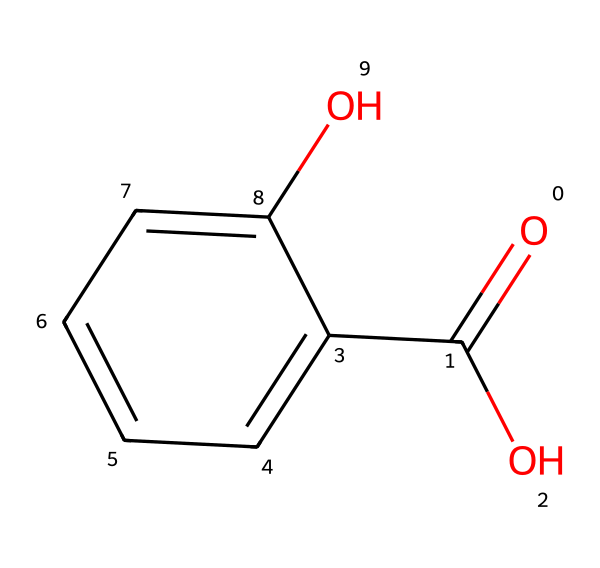What is the molecular formula of salicylic acid? To deduce the molecular formula, count the number of each type of atom in the SMILES representation: there are 7 carbons (C), 6 hydrogens (H), and 3 oxygens (O), which gives the formula C7H6O3.
Answer: C7H6O3 How many hydroxyl groups are present in salicylic acid? In the chemical structure, look for the -OH functional groups. There is one hydroxyl group attached directly to the benzene ring and another as part of the carboxylic acid, totaling two.
Answer: 2 What type of functional groups are present in salicylic acid? Identify the functional groups in the structure: the presence of both -OH (hydroxyl) and -COOH (carboxylic acid) groups determines the classification.
Answer: hydroxyl, carboxylic acid How many carbon atoms are in the ring structure of salicylic acid? Examine the benzene ring in the structure, which contains 6 carbon atoms. Additionally, there is one carbon in the carboxylic acid group, but it is not part of the ring.
Answer: 6 What effect does the carboxylic acid group have on salicylic acid's solubility? The presence of the -COOH carboxylic acid group increases the compound's polarity due to hydrogen bonding, enhancing its solubility in water.
Answer: increases solubility How does salicylic acid penetrate the skin? Salicylic acid's small molecular size and the presence of the hydroxyl group allow it to dissolve in the lipid layers of the skin, facilitating deeper penetration and effectiveness against acne.
Answer: penetrates deeply What is the primary mechanism of action for salicylic acid in acne treatment? Salicylic acid works primarily by exfoliating the skin and keeping the pores clear of debris, which helps to prevent clogged pores and reduce acne outbreaks.
Answer: exfoliation 